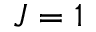<formula> <loc_0><loc_0><loc_500><loc_500>J = 1</formula> 